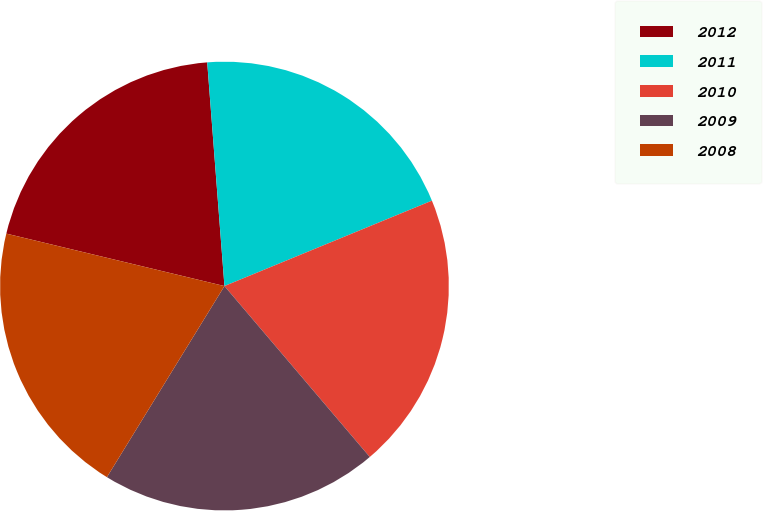<chart> <loc_0><loc_0><loc_500><loc_500><pie_chart><fcel>2012<fcel>2011<fcel>2010<fcel>2009<fcel>2008<nl><fcel>20.02%<fcel>20.01%<fcel>20.0%<fcel>19.99%<fcel>19.98%<nl></chart> 